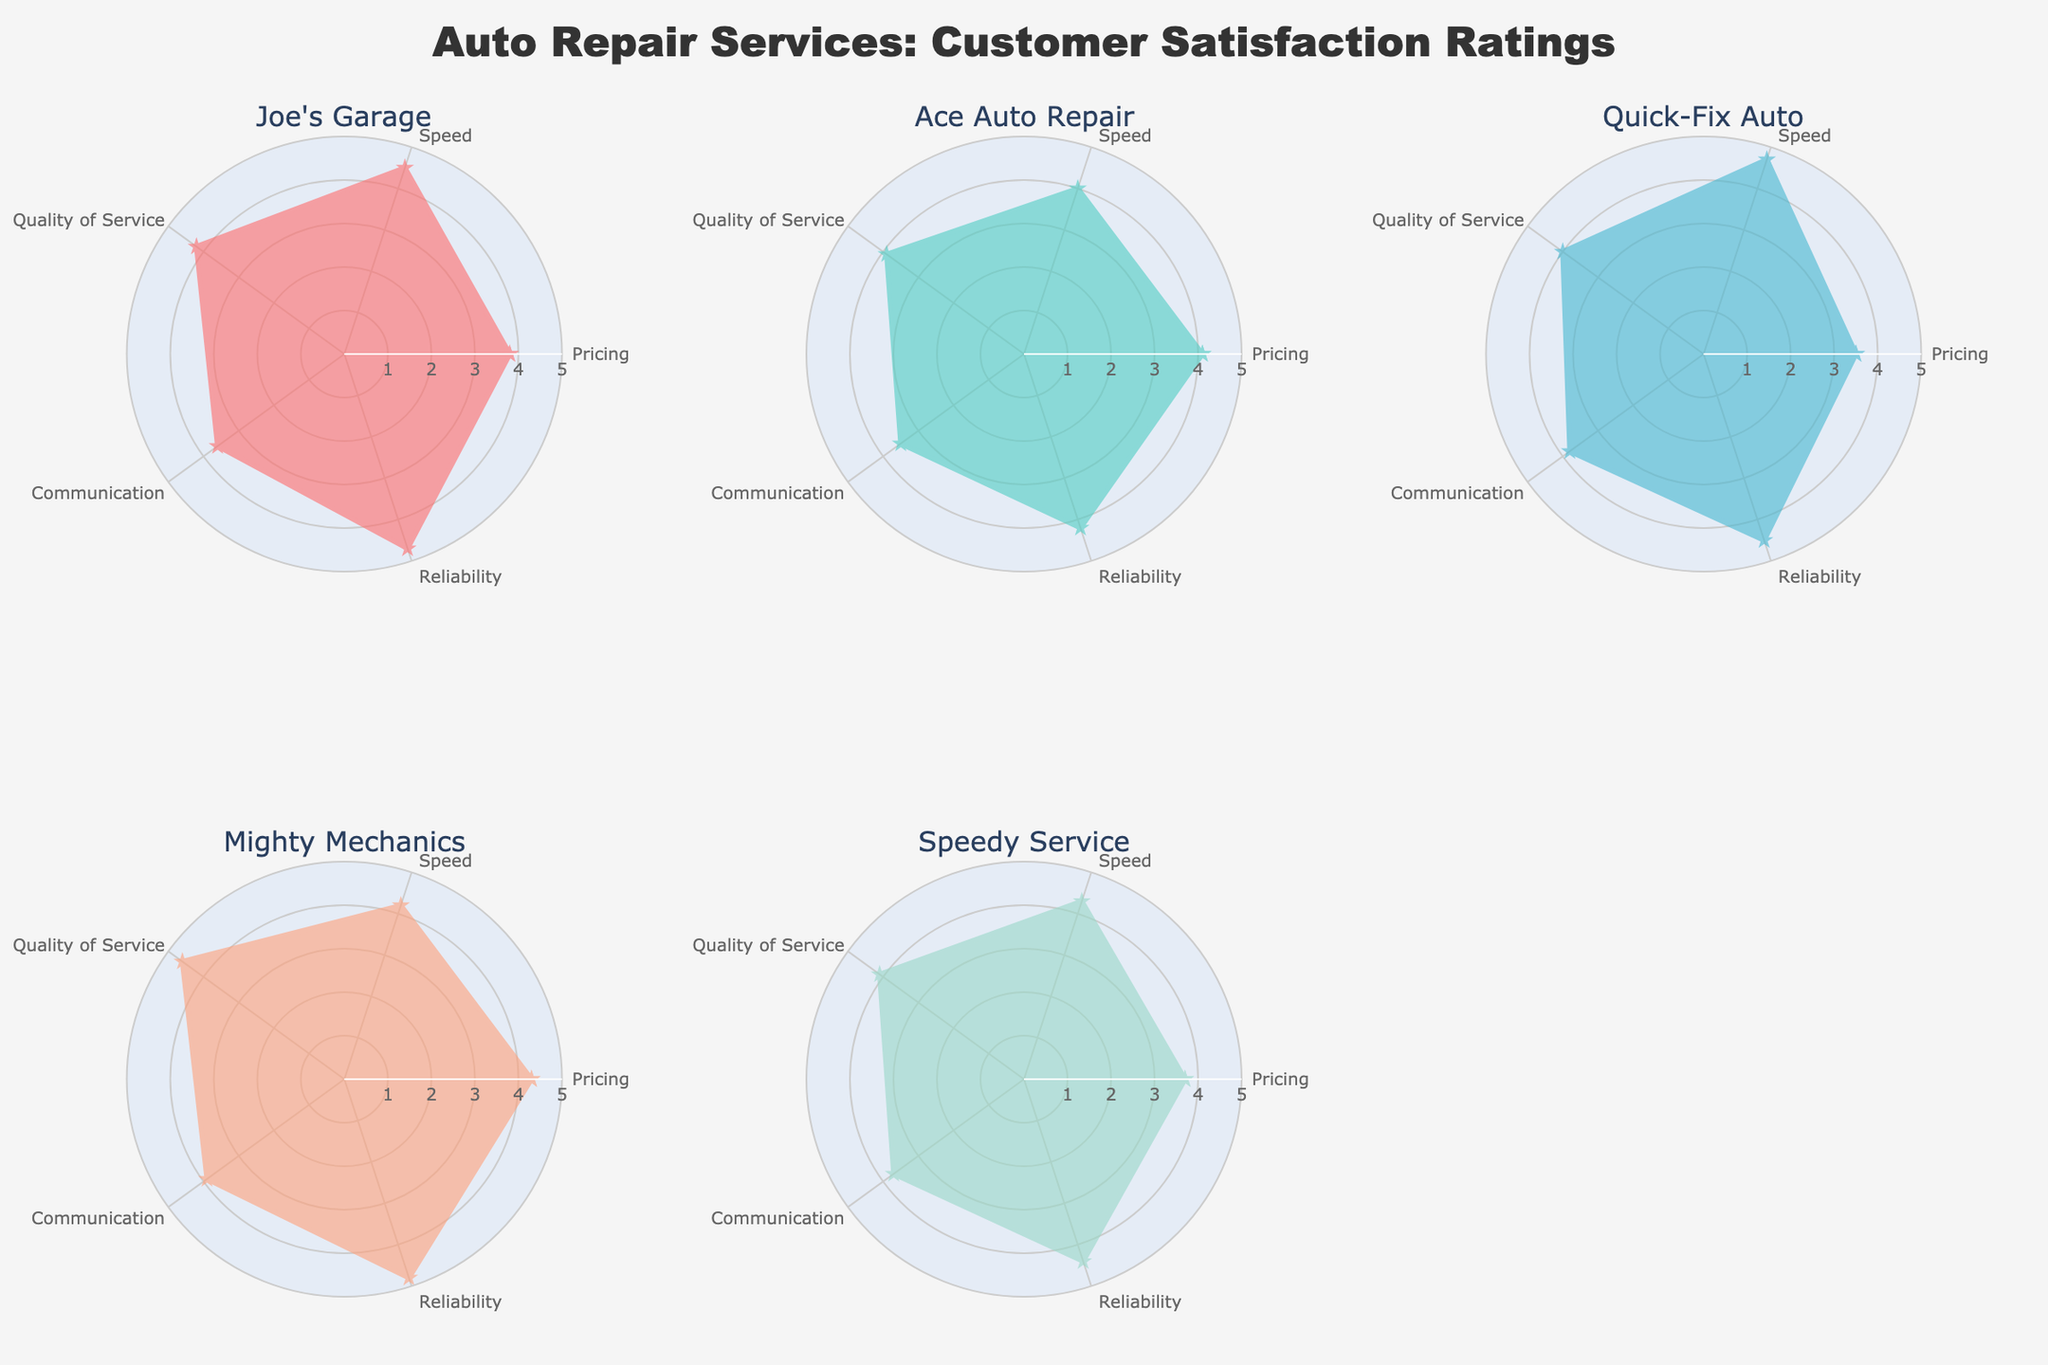What's the highest customer rating for Joe's Garage? The ratings for Joe's Garage are as follows: Pricing - 3.8, Speed - 4.5, Quality of Service - 4.2, Communication - 3.6, Reliability - 4.7. The highest rating is for Reliability.
Answer: 4.7 Which service has the lowest rating in Communication? The ratings for Communication are: Joe's Garage - 3.6, Ace Auto Repair - 3.5, Quick-Fix Auto - 3.8, Mighty Mechanics - 3.9, Speedy Service - 3.7. The lowest rating is for Ace Auto Repair.
Answer: Ace Auto Repair What's the average rating for Speed among all services? The ratings for Speed are: Joe's Garage - 4.5, Ace Auto Repair - 4.0, Quick-Fix Auto - 4.7, Mighty Mechanics - 4.2, Speedy Service - 4.3. The average is (4.5 + 4.0 + 4.7 + 4.2 + 4.3)/5 = 4.34
Answer: 4.34 How does the Quality of Service rating for Mighty Mechanics compare to Speedy Service? The Quality of Service rating for Mighty Mechanics is 4.6, and for Speedy Service, it's 4.1. Hence, Mighty Mechanics has a higher Quality of Service rating compared to Speedy Service.
Answer: Mighty Mechanics is higher Among all the services, which one shows the highest rating in any category, and what is that rating? The highest ratings in each category are: Pricing - Mighty Mechanics 4.3, Speed - Quick-Fix Auto 4.7, Quality of Service - Mighty Mechanics 4.6, Communication - Mighty Mechanics 3.9, Reliability - Mighty Mechanics 4.8. The highest overall rating is Reliability for Mighty Mechanics.
Answer: 4.8 